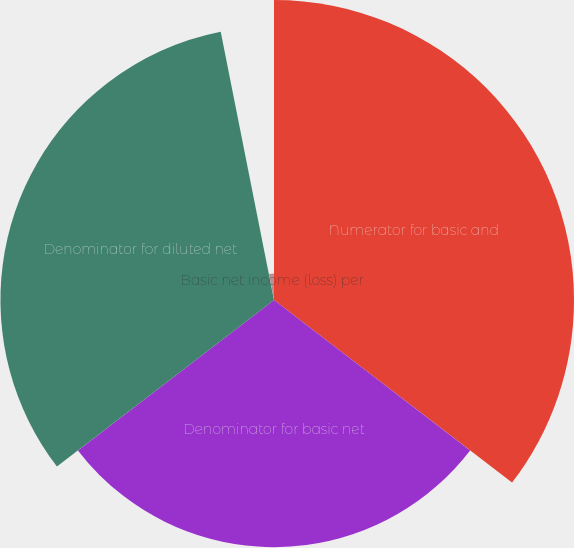Convert chart. <chart><loc_0><loc_0><loc_500><loc_500><pie_chart><fcel>Numerator for basic and<fcel>Denominator for basic net<fcel>Denominator for diluted net<fcel>Basic net income (loss) per<fcel>Diluted net income (loss) per<nl><fcel>35.41%<fcel>29.17%<fcel>32.29%<fcel>3.12%<fcel>0.0%<nl></chart> 